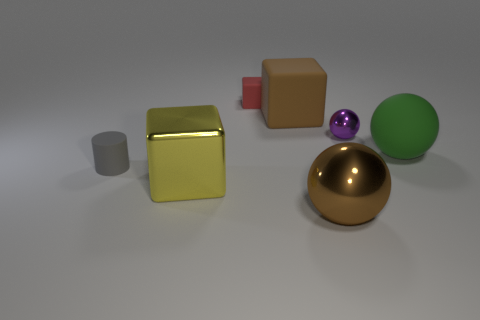What can you tell me about the lighting in this scene? The lighting in the scene is quite soft and diffused, suggesting an overhead source possibly simulating an overcast sky. The lack of harsh shadows indicates that the light source is not very close to the objects. The smooth gradient in the shadows' intensity on the floor suggests a broad light source with a gentle falloff. 